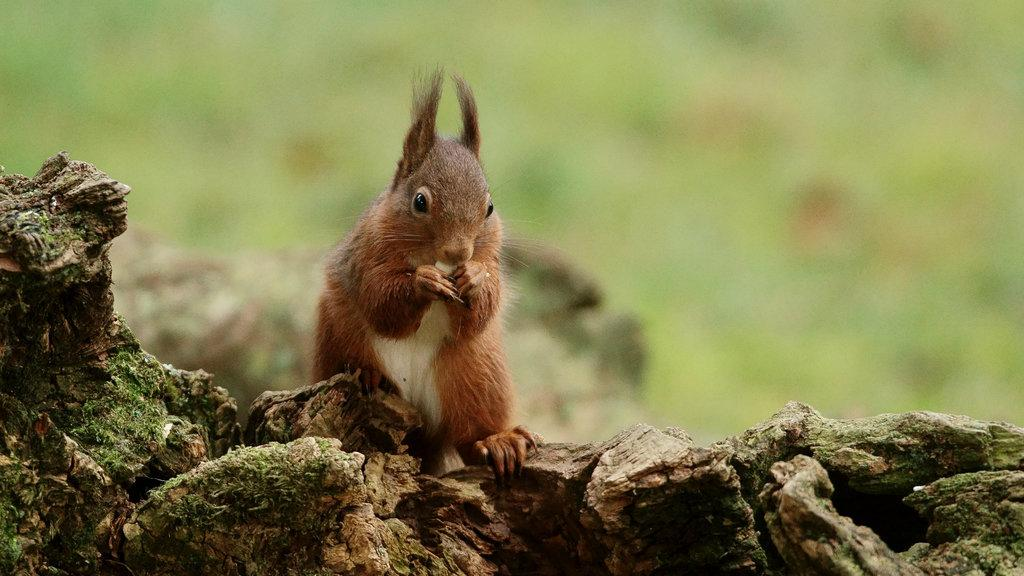What animal can be seen in the image? There is a squirrel in the image. Where is the squirrel located? The squirrel is sitting on a branch. Is the squirrel sitting on a seat in the image? No, the squirrel is sitting on a branch, not a seat. Can you tell me what the secretary is doing in the image? There is no secretary present in the image; it only features a squirrel sitting on a branch. 